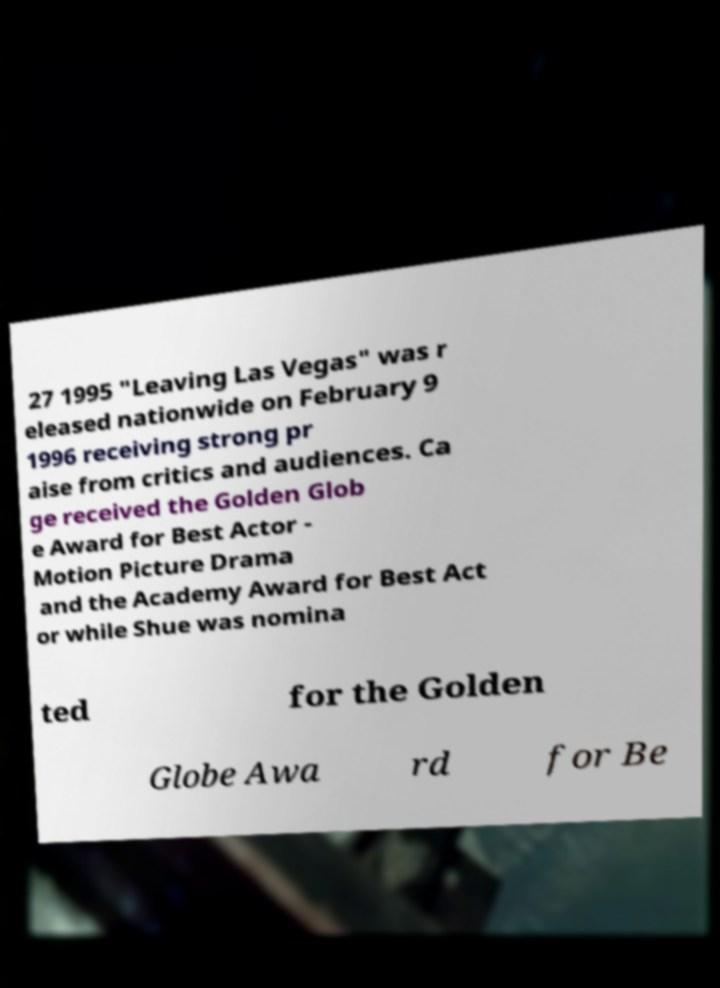What messages or text are displayed in this image? I need them in a readable, typed format. 27 1995 "Leaving Las Vegas" was r eleased nationwide on February 9 1996 receiving strong pr aise from critics and audiences. Ca ge received the Golden Glob e Award for Best Actor - Motion Picture Drama and the Academy Award for Best Act or while Shue was nomina ted for the Golden Globe Awa rd for Be 